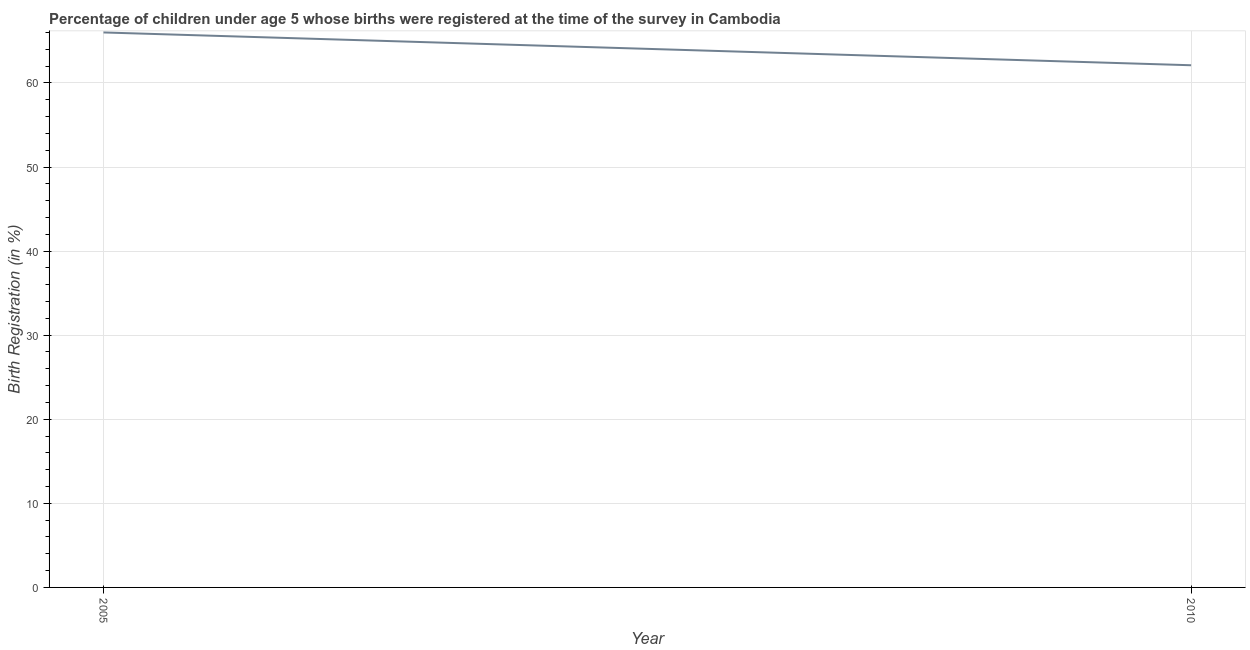Across all years, what is the minimum birth registration?
Make the answer very short. 62.1. In which year was the birth registration minimum?
Ensure brevity in your answer.  2010. What is the sum of the birth registration?
Give a very brief answer. 128.1. What is the difference between the birth registration in 2005 and 2010?
Ensure brevity in your answer.  3.9. What is the average birth registration per year?
Ensure brevity in your answer.  64.05. What is the median birth registration?
Give a very brief answer. 64.05. In how many years, is the birth registration greater than 34 %?
Your answer should be compact. 2. Do a majority of the years between 2010 and 2005 (inclusive) have birth registration greater than 52 %?
Provide a short and direct response. No. What is the ratio of the birth registration in 2005 to that in 2010?
Give a very brief answer. 1.06. In how many years, is the birth registration greater than the average birth registration taken over all years?
Provide a short and direct response. 1. How many years are there in the graph?
Ensure brevity in your answer.  2. Are the values on the major ticks of Y-axis written in scientific E-notation?
Provide a short and direct response. No. What is the title of the graph?
Ensure brevity in your answer.  Percentage of children under age 5 whose births were registered at the time of the survey in Cambodia. What is the label or title of the Y-axis?
Make the answer very short. Birth Registration (in %). What is the Birth Registration (in %) in 2010?
Provide a short and direct response. 62.1. What is the difference between the Birth Registration (in %) in 2005 and 2010?
Offer a terse response. 3.9. What is the ratio of the Birth Registration (in %) in 2005 to that in 2010?
Ensure brevity in your answer.  1.06. 